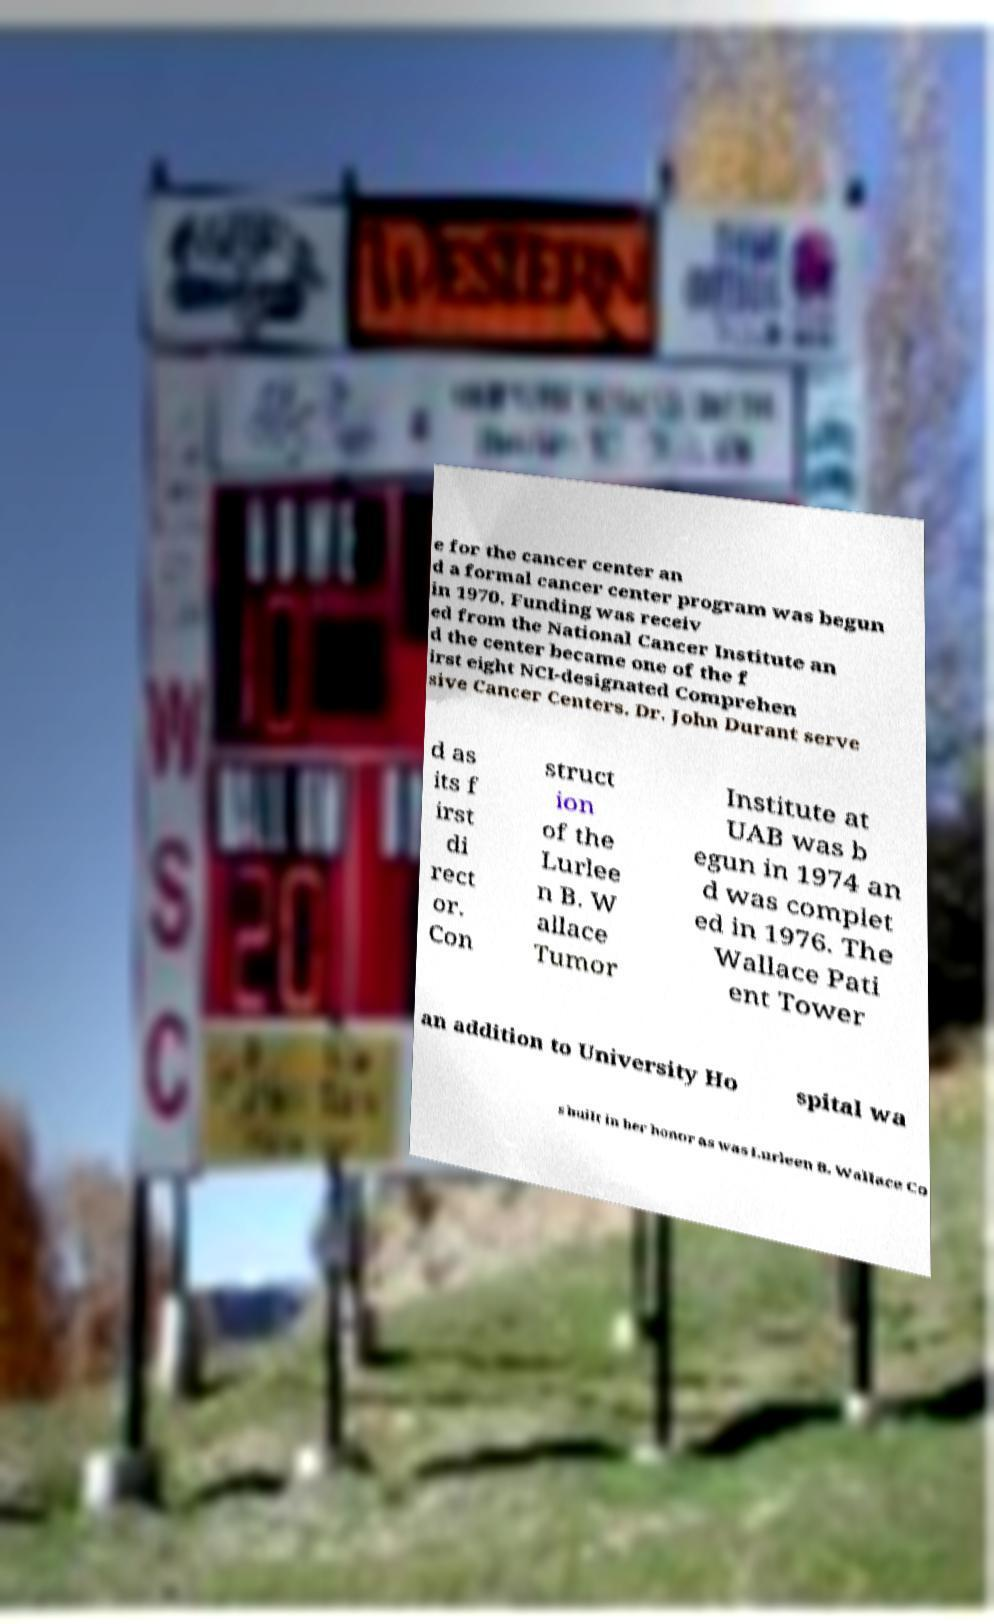What messages or text are displayed in this image? I need them in a readable, typed format. e for the cancer center an d a formal cancer center program was begun in 1970. Funding was receiv ed from the National Cancer Institute an d the center became one of the f irst eight NCI-designated Comprehen sive Cancer Centers. Dr. John Durant serve d as its f irst di rect or. Con struct ion of the Lurlee n B. W allace Tumor Institute at UAB was b egun in 1974 an d was complet ed in 1976. The Wallace Pati ent Tower an addition to University Ho spital wa s built in her honor as was Lurleen B. Wallace Co 